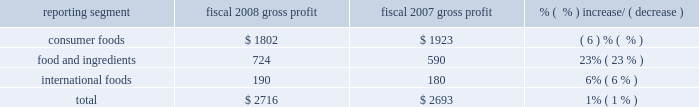Consumer foods net sales increased $ 303 million , or 5% ( 5 % ) , for the year to $ 6.8 billion .
Results reflect an increase of three percentage points from improved net pricing and product mix and two percentage points of improvement from higher volumes .
Net pricing and volume improvements were achieved in many of the company 2019s priority investment and enabler brands .
The impact of product recalls partially offset these improvements .
The company implemented significant price increases for many consumer foods products during the fourth quarter of fiscal 2008 .
Continued net sales improvements are expected into fiscal 2009 when the company expects to receive the benefit of these pricing actions for full fiscal periods .
Sales of some of the company 2019s most significant brands , including chef boyardee ae , david ae , egg beaters ae , healthy choice ae , hebrew national ae , hunt 2019s ae , marie callender 2019s ae , manwich ae , orville redenbacher 2019s ae , pam ae , ro*tel ae , rosarita ae , snack pack ae , swiss miss ae , wesson ae , and wolf ae grew in fiscal 2008 .
Sales of act ii ae , andy capp ae , banquet ae , crunch 2018n munch ae , kid cuisine ae , parkay ae , pemmican ae , reddi-wip ae , and slim jim ae declined in fiscal 2008 .
Net sales in the consumer foods segment are not comparable across periods due to a variety of factors .
The company initiated a peanut butter recall in the third quarter of fiscal 2007 and reintroduced peter pan ae peanut butter products in august 2007 .
Sales of all peanut butter products , including both branded and private label , in fiscal 2008 were $ 14 million lower than comparable amounts in fiscal 2007 .
Consumer foods net sales were also adversely impacted by the recall of banquet ae and private label pot pies in the second quarter of fiscal 2008 .
Net sales of pot pies were lower by approximately $ 22 million in fiscal 2008 , relative to fiscal 2007 , primarily due to product returns and lost sales of banquet ae and private label pot pies .
Sales from alexia foods and lincoln snacks , businesses acquired in fiscal 2008 , totaled $ 66 million in fiscal 2008 .
The company divested a refrigerated pizza business during the first half of fiscal 2007 .
Sales from this business were $ 17 million in fiscal food and ingredients net sales were $ 4.1 billion in fiscal 2008 , an increase of $ 706 million , or 21% ( 21 % ) .
Increased sales are reflective of higher sales prices in the company 2019s milling operations due to higher grain prices , and price and volume increases in the company 2019s potato and dehydrated vegetable operations .
The fiscal 2007 divestiture of an oat milling operation resulted in a reduction of sales of $ 27 million for fiscal 2008 , partially offset by increased sales of $ 18 million from the acquisition of watts brothers in february 2008 .
International foods net sales increased $ 65 million to $ 678 million .
The strengthening of foreign currencies relative to the u.s .
Dollar accounted for approximately $ 36 million of this increase .
The segment achieved a 5% ( 5 % ) increase in sales volume in fiscal 2008 , primarily reflecting increased unit sales in canada and mexico , and modest increases in net pricing .
Gross profit ( net sales less cost of goods sold ) ( $ in millions ) reporting segment fiscal 2008 gross profit fiscal 2007 gross profit % (  % ) increase/ ( decrease ) .
The company 2019s gross profit for fiscal 2008 was $ 2.7 billion , an increase of $ 23 million , or 1% ( 1 % ) , over the prior year .
The increase in gross profit was largely driven by results in the food and ingredients segment , reflecting higher margins in the company 2019s milling and specialty potato operations , largely offset by reduced gross profits in the consumer foods segment .
Costs of implementing the company 2019s restructuring plans reduced gross profit by $ 4 million and $ 46 million in fiscal 2008 and fiscal 2007 , respectively. .
What percent of total gross profit in fiscal 2008 was contributed by consumer foods? 
Computations: (1802 / 2716)
Answer: 0.66348. 